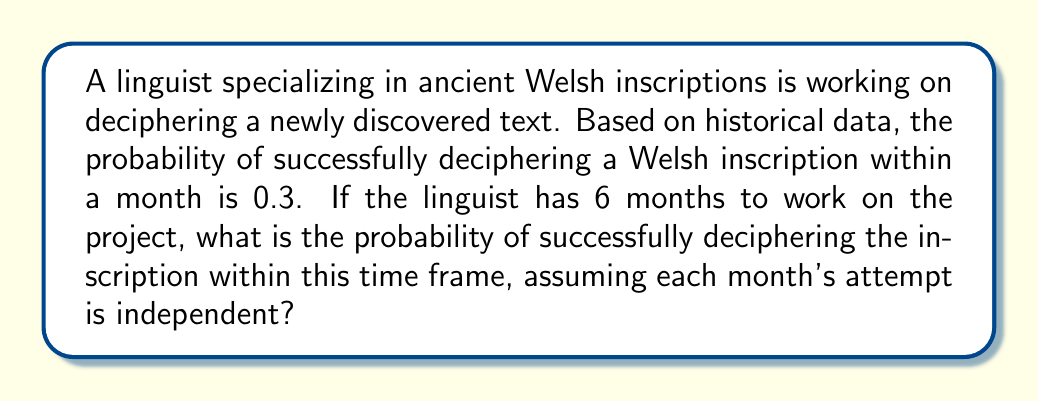Could you help me with this problem? To solve this problem, we need to use the concept of probability of independent events. Specifically, we're looking at the probability of at least one success in multiple independent trials.

Let's break it down step-by-step:

1) First, let's define our variables:
   $p$ = probability of success in one month = 0.3
   $q$ = probability of failure in one month = 1 - p = 0.7
   $n$ = number of months = 6

2) We want to find the probability of success within 6 months. This is equivalent to 1 minus the probability of failing all 6 months.

3) The probability of failing all 6 months is:
   $q^n = 0.7^6$

4) Therefore, the probability of success within 6 months is:
   $1 - q^n = 1 - 0.7^6$

5) Let's calculate this:
   $1 - 0.7^6 = 1 - 0.117649 = 0.882351$

6) We can express this as a percentage:
   $0.882351 * 100\% = 88.2351\%$

This means the linguist has approximately an 88.24% chance of deciphering the inscription within the given 6-month timeframe.
Answer: The probability of successfully deciphering the ancient Welsh inscription within 6 months is approximately $0.882351$ or $88.24\%$. 